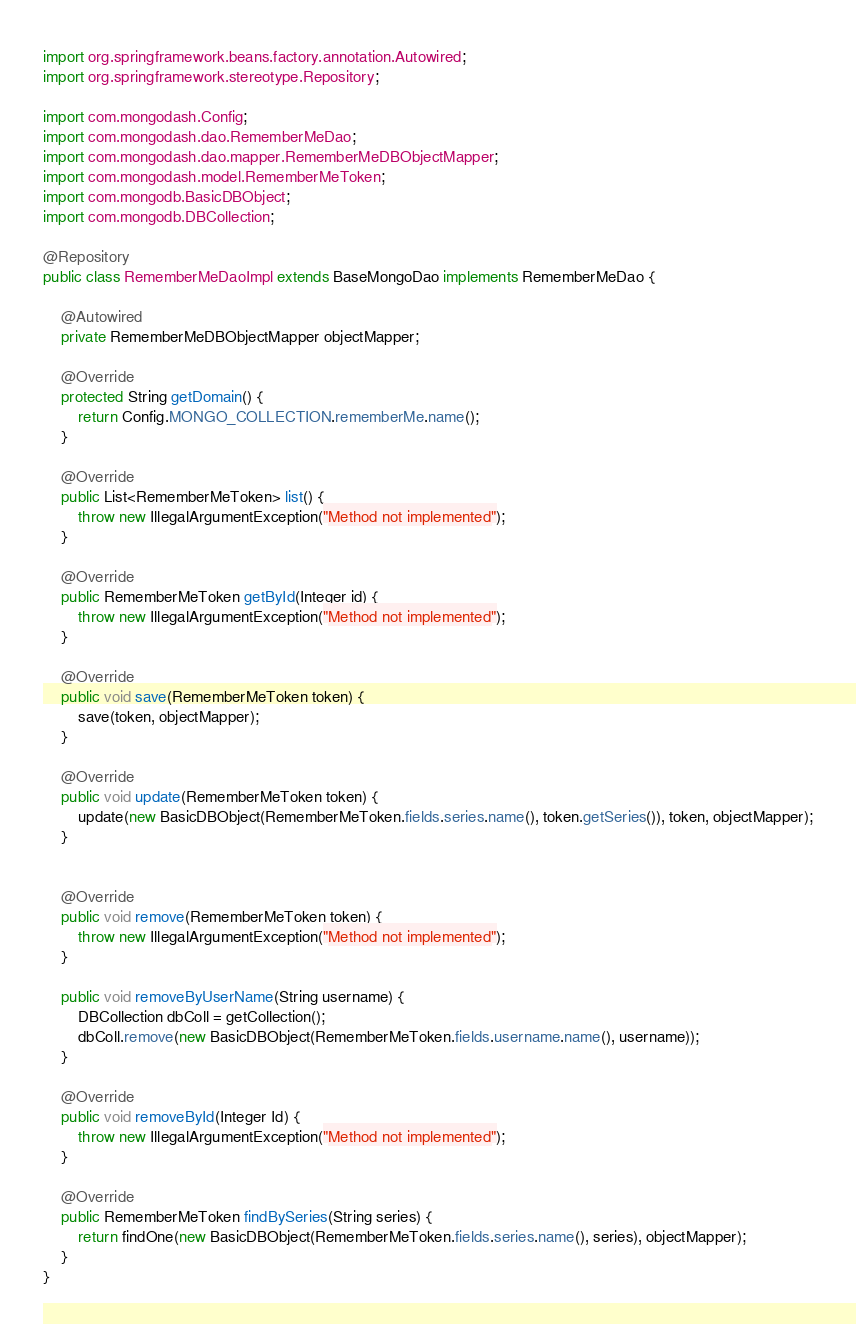<code> <loc_0><loc_0><loc_500><loc_500><_Java_>import org.springframework.beans.factory.annotation.Autowired;
import org.springframework.stereotype.Repository;

import com.mongodash.Config;
import com.mongodash.dao.RememberMeDao;
import com.mongodash.dao.mapper.RememberMeDBObjectMapper;
import com.mongodash.model.RememberMeToken;
import com.mongodb.BasicDBObject;
import com.mongodb.DBCollection;

@Repository
public class RememberMeDaoImpl extends BaseMongoDao implements RememberMeDao {

	@Autowired
	private RememberMeDBObjectMapper objectMapper;

	@Override
	protected String getDomain() {
		return Config.MONGO_COLLECTION.rememberMe.name();
	}

	@Override
	public List<RememberMeToken> list() {
		throw new IllegalArgumentException("Method not implemented");
	}

	@Override
	public RememberMeToken getById(Integer id) {
		throw new IllegalArgumentException("Method not implemented");
	}

	@Override
	public void save(RememberMeToken token) {
		save(token, objectMapper);
	}

	@Override
	public void update(RememberMeToken token) {
		update(new BasicDBObject(RememberMeToken.fields.series.name(), token.getSeries()), token, objectMapper);
	}
	

	@Override
	public void remove(RememberMeToken token) {
		throw new IllegalArgumentException("Method not implemented");
	}
	
	public void removeByUserName(String username) {
		DBCollection dbColl = getCollection();
		dbColl.remove(new BasicDBObject(RememberMeToken.fields.username.name(), username));
	}

	@Override
	public void removeById(Integer Id) {
		throw new IllegalArgumentException("Method not implemented");
	}

	@Override
	public RememberMeToken findBySeries(String series) {
		return findOne(new BasicDBObject(RememberMeToken.fields.series.name(), series), objectMapper);
	}
}
</code> 